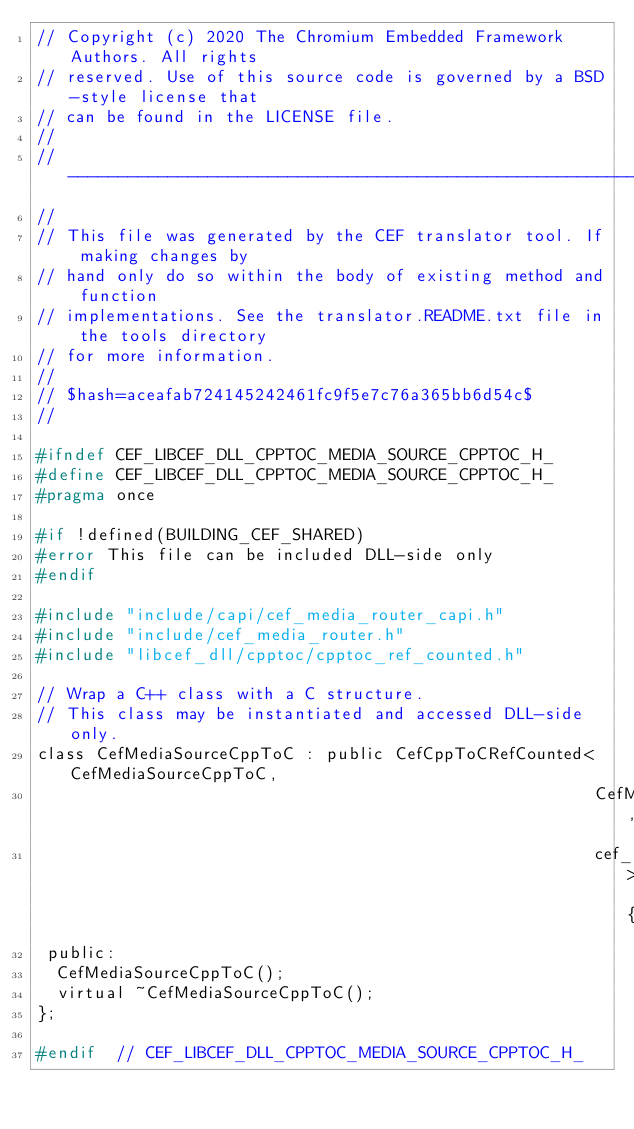Convert code to text. <code><loc_0><loc_0><loc_500><loc_500><_C_>// Copyright (c) 2020 The Chromium Embedded Framework Authors. All rights
// reserved. Use of this source code is governed by a BSD-style license that
// can be found in the LICENSE file.
//
// ---------------------------------------------------------------------------
//
// This file was generated by the CEF translator tool. If making changes by
// hand only do so within the body of existing method and function
// implementations. See the translator.README.txt file in the tools directory
// for more information.
//
// $hash=aceafab724145242461fc9f5e7c76a365bb6d54c$
//

#ifndef CEF_LIBCEF_DLL_CPPTOC_MEDIA_SOURCE_CPPTOC_H_
#define CEF_LIBCEF_DLL_CPPTOC_MEDIA_SOURCE_CPPTOC_H_
#pragma once

#if !defined(BUILDING_CEF_SHARED)
#error This file can be included DLL-side only
#endif

#include "include/capi/cef_media_router_capi.h"
#include "include/cef_media_router.h"
#include "libcef_dll/cpptoc/cpptoc_ref_counted.h"

// Wrap a C++ class with a C structure.
// This class may be instantiated and accessed DLL-side only.
class CefMediaSourceCppToC : public CefCppToCRefCounted<CefMediaSourceCppToC,
                                                        CefMediaSource,
                                                        cef_media_source_t> {
 public:
  CefMediaSourceCppToC();
  virtual ~CefMediaSourceCppToC();
};

#endif  // CEF_LIBCEF_DLL_CPPTOC_MEDIA_SOURCE_CPPTOC_H_
</code> 